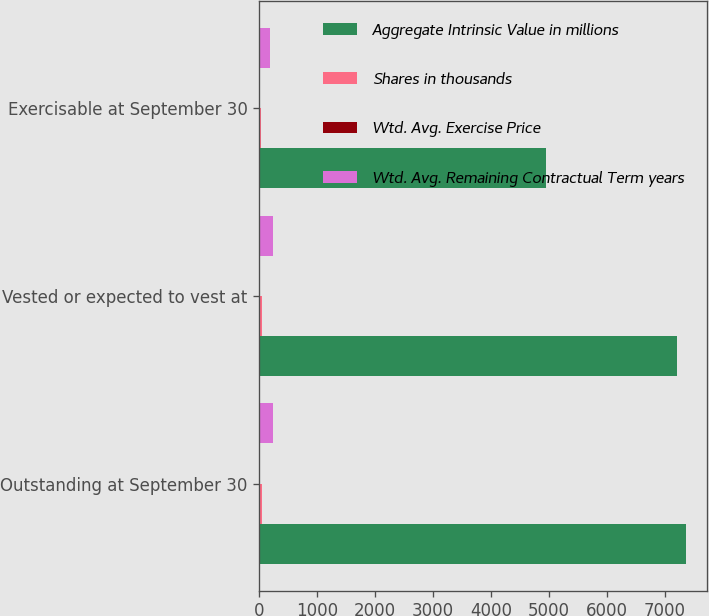Convert chart to OTSL. <chart><loc_0><loc_0><loc_500><loc_500><stacked_bar_chart><ecel><fcel>Outstanding at September 30<fcel>Vested or expected to vest at<fcel>Exercisable at September 30<nl><fcel>Aggregate Intrinsic Value in millions<fcel>7363<fcel>7221<fcel>4947<nl><fcel>Shares in thousands<fcel>38.17<fcel>37.81<fcel>21.86<nl><fcel>Wtd. Avg. Exercise Price<fcel>6.4<fcel>6.4<fcel>5.5<nl><fcel>Wtd. Avg. Remaining Contractual Term years<fcel>230.7<fcel>228.9<fcel>179.3<nl></chart> 